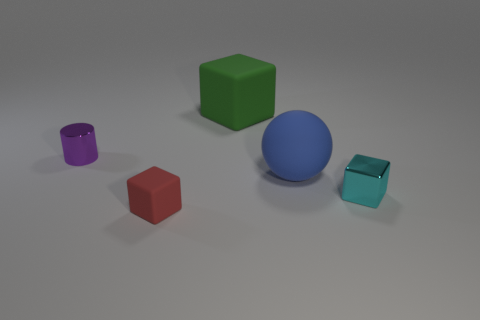Add 4 tiny cyan metallic blocks. How many objects exist? 9 Subtract all spheres. How many objects are left? 4 Add 5 big blue spheres. How many big blue spheres exist? 6 Subtract 1 cyan blocks. How many objects are left? 4 Subtract all blue matte things. Subtract all small cylinders. How many objects are left? 3 Add 4 big balls. How many big balls are left? 5 